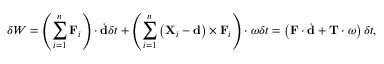<formula> <loc_0><loc_0><loc_500><loc_500>\delta W = \left ( \sum _ { i = 1 } ^ { n } F _ { i } \right ) \cdot { \dot { d } } \delta t + \left ( \sum _ { i = 1 } ^ { n } \left ( X _ { i } - d \right ) \times F _ { i } \right ) \cdot { \omega } \delta t = \left ( F \cdot { \dot { d } } + T \cdot { \omega } \right ) \delta t ,</formula> 